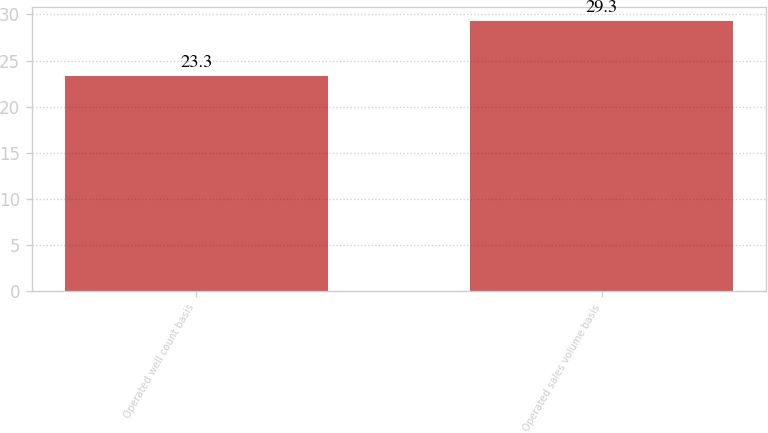Convert chart. <chart><loc_0><loc_0><loc_500><loc_500><bar_chart><fcel>Operated well count basis<fcel>Operated sales volume basis<nl><fcel>23.3<fcel>29.3<nl></chart> 